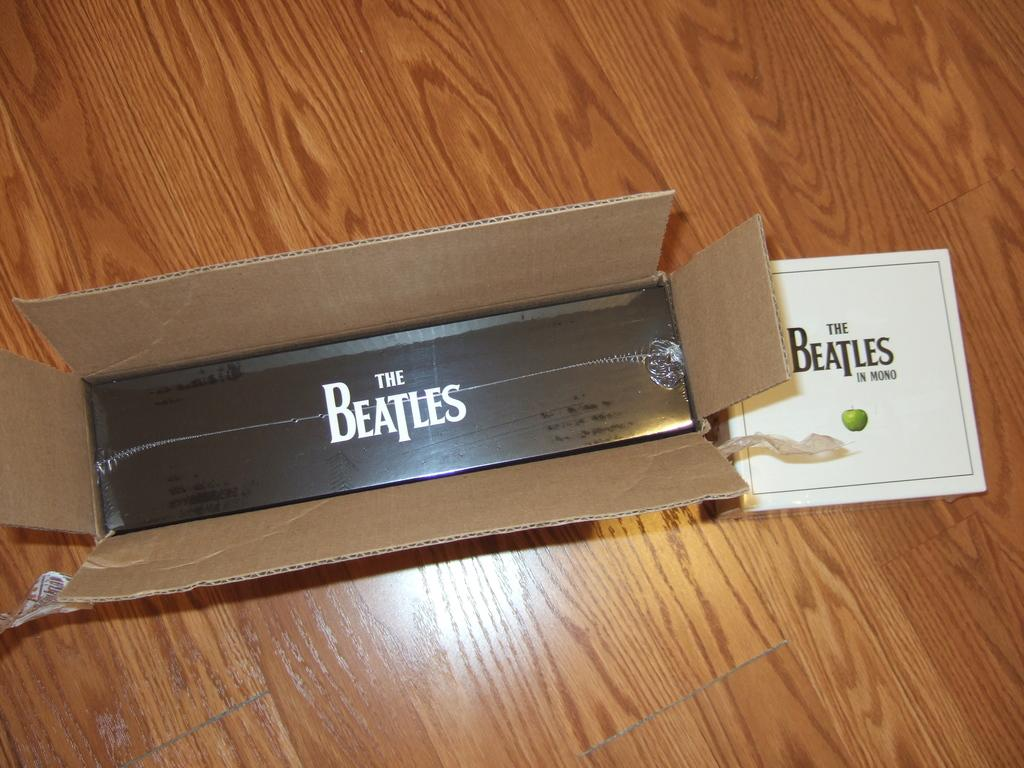Provide a one-sentence caption for the provided image. A box that has been opened showing the content to be Beatles products. 